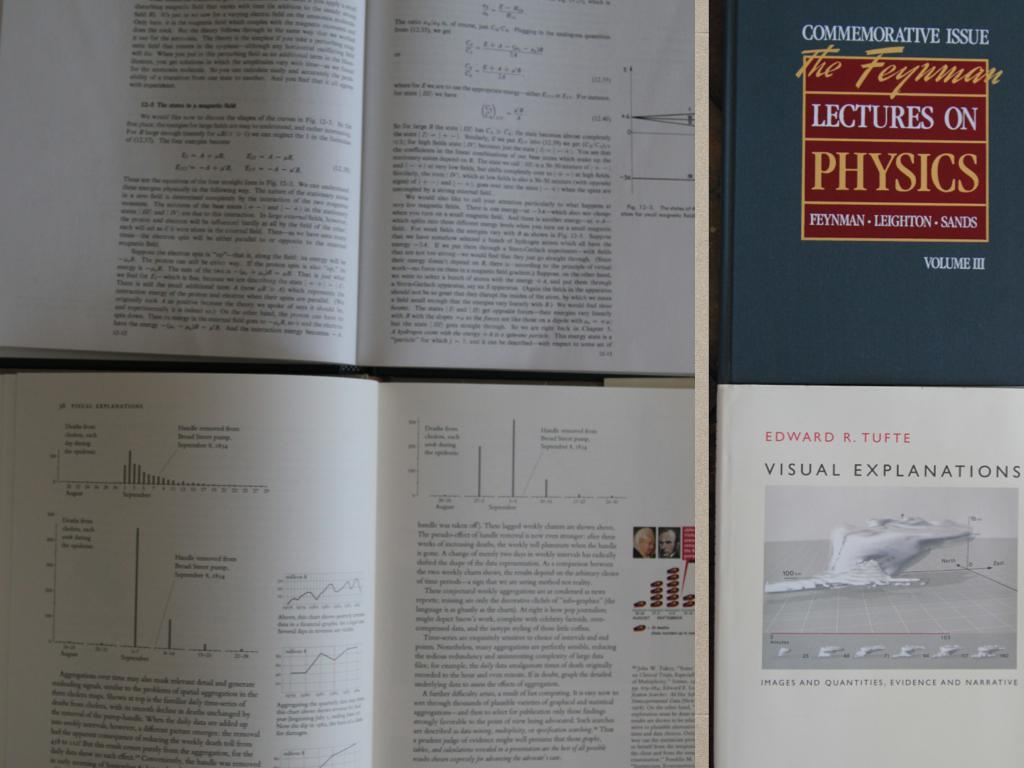<image>
Describe the image concisely. A blue book titled Lectures on Physics sits on a table. 